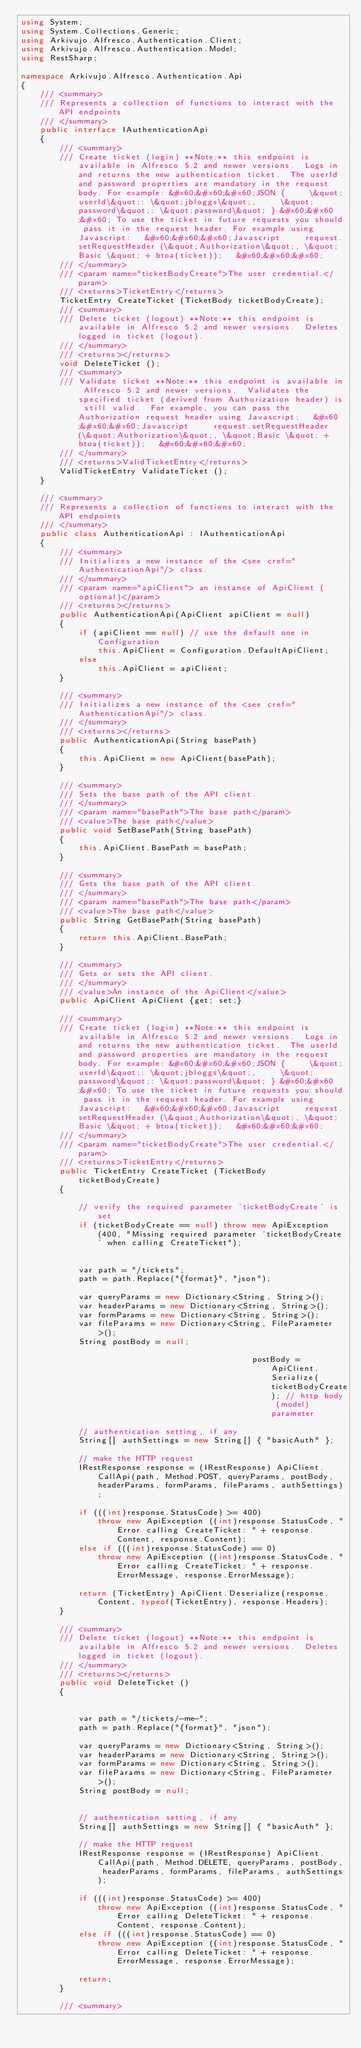Convert code to text. <code><loc_0><loc_0><loc_500><loc_500><_C#_>using System;
using System.Collections.Generic;
using Arkivujo.Alfresco.Authentication.Client;
using Arkivujo.Alfresco.Authentication.Model;
using RestSharp;

namespace Arkivujo.Alfresco.Authentication.Api
{
    /// <summary>
    /// Represents a collection of functions to interact with the API endpoints
    /// </summary>
    public interface IAuthenticationApi
    {
        /// <summary>
        /// Create ticket (login) **Note:** this endpoint is available in Alfresco 5.2 and newer versions.  Logs in and returns the new authentication ticket.  The userId and password properties are mandatory in the request body. For example: &#x60;&#x60;&#x60;JSON {     \&quot;userId\&quot;: \&quot;jbloggs\&quot;,     \&quot;password\&quot;: \&quot;password\&quot; } &#x60;&#x60;&#x60; To use the ticket in future requests you should pass it in the request header. For example using Javascript:   &#x60;&#x60;&#x60;Javascript     request.setRequestHeader (\&quot;Authorization\&quot;, \&quot;Basic \&quot; + btoa(ticket));   &#x60;&#x60;&#x60; 
        /// </summary>
        /// <param name="ticketBodyCreate">The user credential.</param>
        /// <returns>TicketEntry</returns>
        TicketEntry CreateTicket (TicketBody ticketBodyCreate);
        /// <summary>
        /// Delete ticket (logout) **Note:** this endpoint is available in Alfresco 5.2 and newer versions.  Deletes logged in ticket (logout). 
        /// </summary>
        /// <returns></returns>
        void DeleteTicket ();
        /// <summary>
        /// Validate ticket **Note:** this endpoint is available in Alfresco 5.2 and newer versions.  Validates the specified ticket (derived from Authorization header) is still valid.  For example, you can pass the Authorization request header using Javascript:   &#x60;&#x60;&#x60;Javascript     request.setRequestHeader (\&quot;Authorization\&quot;, \&quot;Basic \&quot; + btoa(ticket));   &#x60;&#x60;&#x60; 
        /// </summary>
        /// <returns>ValidTicketEntry</returns>
        ValidTicketEntry ValidateTicket ();
    }
  
    /// <summary>
    /// Represents a collection of functions to interact with the API endpoints
    /// </summary>
    public class AuthenticationApi : IAuthenticationApi
    {
        /// <summary>
        /// Initializes a new instance of the <see cref="AuthenticationApi"/> class.
        /// </summary>
        /// <param name="apiClient"> an instance of ApiClient (optional)</param>
        /// <returns></returns>
        public AuthenticationApi(ApiClient apiClient = null)
        {
            if (apiClient == null) // use the default one in Configuration
                this.ApiClient = Configuration.DefaultApiClient; 
            else
                this.ApiClient = apiClient;
        }
    
        /// <summary>
        /// Initializes a new instance of the <see cref="AuthenticationApi"/> class.
        /// </summary>
        /// <returns></returns>
        public AuthenticationApi(String basePath)
        {
            this.ApiClient = new ApiClient(basePath);
        }
    
        /// <summary>
        /// Sets the base path of the API client.
        /// </summary>
        /// <param name="basePath">The base path</param>
        /// <value>The base path</value>
        public void SetBasePath(String basePath)
        {
            this.ApiClient.BasePath = basePath;
        }
    
        /// <summary>
        /// Gets the base path of the API client.
        /// </summary>
        /// <param name="basePath">The base path</param>
        /// <value>The base path</value>
        public String GetBasePath(String basePath)
        {
            return this.ApiClient.BasePath;
        }
    
        /// <summary>
        /// Gets or sets the API client.
        /// </summary>
        /// <value>An instance of the ApiClient</value>
        public ApiClient ApiClient {get; set;}
    
        /// <summary>
        /// Create ticket (login) **Note:** this endpoint is available in Alfresco 5.2 and newer versions.  Logs in and returns the new authentication ticket.  The userId and password properties are mandatory in the request body. For example: &#x60;&#x60;&#x60;JSON {     \&quot;userId\&quot;: \&quot;jbloggs\&quot;,     \&quot;password\&quot;: \&quot;password\&quot; } &#x60;&#x60;&#x60; To use the ticket in future requests you should pass it in the request header. For example using Javascript:   &#x60;&#x60;&#x60;Javascript     request.setRequestHeader (\&quot;Authorization\&quot;, \&quot;Basic \&quot; + btoa(ticket));   &#x60;&#x60;&#x60; 
        /// </summary>
        /// <param name="ticketBodyCreate">The user credential.</param> 
        /// <returns>TicketEntry</returns>            
        public TicketEntry CreateTicket (TicketBody ticketBodyCreate)
        {
            
            // verify the required parameter 'ticketBodyCreate' is set
            if (ticketBodyCreate == null) throw new ApiException(400, "Missing required parameter 'ticketBodyCreate' when calling CreateTicket");
            
    
            var path = "/tickets";
            path = path.Replace("{format}", "json");
                
            var queryParams = new Dictionary<String, String>();
            var headerParams = new Dictionary<String, String>();
            var formParams = new Dictionary<String, String>();
            var fileParams = new Dictionary<String, FileParameter>();
            String postBody = null;
    
                                                postBody = ApiClient.Serialize(ticketBodyCreate); // http body (model) parameter
    
            // authentication setting, if any
            String[] authSettings = new String[] { "basicAuth" };
    
            // make the HTTP request
            IRestResponse response = (IRestResponse) ApiClient.CallApi(path, Method.POST, queryParams, postBody, headerParams, formParams, fileParams, authSettings);
    
            if (((int)response.StatusCode) >= 400)
                throw new ApiException ((int)response.StatusCode, "Error calling CreateTicket: " + response.Content, response.Content);
            else if (((int)response.StatusCode) == 0)
                throw new ApiException ((int)response.StatusCode, "Error calling CreateTicket: " + response.ErrorMessage, response.ErrorMessage);
    
            return (TicketEntry) ApiClient.Deserialize(response.Content, typeof(TicketEntry), response.Headers);
        }
    
        /// <summary>
        /// Delete ticket (logout) **Note:** this endpoint is available in Alfresco 5.2 and newer versions.  Deletes logged in ticket (logout). 
        /// </summary>
        /// <returns></returns>            
        public void DeleteTicket ()
        {
            
    
            var path = "/tickets/-me-";
            path = path.Replace("{format}", "json");
                
            var queryParams = new Dictionary<String, String>();
            var headerParams = new Dictionary<String, String>();
            var formParams = new Dictionary<String, String>();
            var fileParams = new Dictionary<String, FileParameter>();
            String postBody = null;
    
                                                    
            // authentication setting, if any
            String[] authSettings = new String[] { "basicAuth" };
    
            // make the HTTP request
            IRestResponse response = (IRestResponse) ApiClient.CallApi(path, Method.DELETE, queryParams, postBody, headerParams, formParams, fileParams, authSettings);
    
            if (((int)response.StatusCode) >= 400)
                throw new ApiException ((int)response.StatusCode, "Error calling DeleteTicket: " + response.Content, response.Content);
            else if (((int)response.StatusCode) == 0)
                throw new ApiException ((int)response.StatusCode, "Error calling DeleteTicket: " + response.ErrorMessage, response.ErrorMessage);
    
            return;
        }
    
        /// <summary></code> 